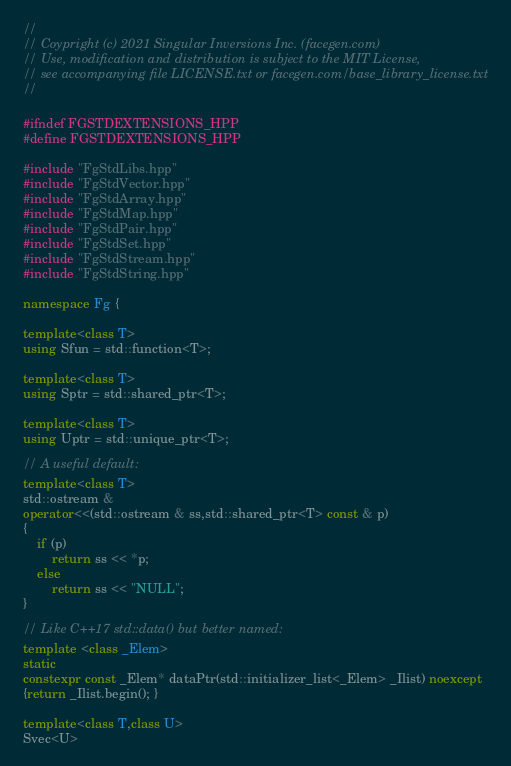<code> <loc_0><loc_0><loc_500><loc_500><_C++_>//
// Coypright (c) 2021 Singular Inversions Inc. (facegen.com)
// Use, modification and distribution is subject to the MIT License,
// see accompanying file LICENSE.txt or facegen.com/base_library_license.txt
//

#ifndef FGSTDEXTENSIONS_HPP
#define FGSTDEXTENSIONS_HPP

#include "FgStdLibs.hpp"
#include "FgStdVector.hpp"
#include "FgStdArray.hpp"
#include "FgStdMap.hpp"
#include "FgStdPair.hpp"
#include "FgStdSet.hpp"
#include "FgStdStream.hpp"
#include "FgStdString.hpp"

namespace Fg {

template<class T>
using Sfun = std::function<T>;

template<class T>
using Sptr = std::shared_ptr<T>;

template<class T>
using Uptr = std::unique_ptr<T>;

// A useful default:
template<class T>
std::ostream &
operator<<(std::ostream & ss,std::shared_ptr<T> const & p)
{
    if (p)
        return ss << *p;
    else
        return ss << "NULL";
}

// Like C++17 std::data() but better named:
template <class _Elem>
static
constexpr const _Elem* dataPtr(std::initializer_list<_Elem> _Ilist) noexcept
{return _Ilist.begin(); }

template<class T,class U>
Svec<U></code> 